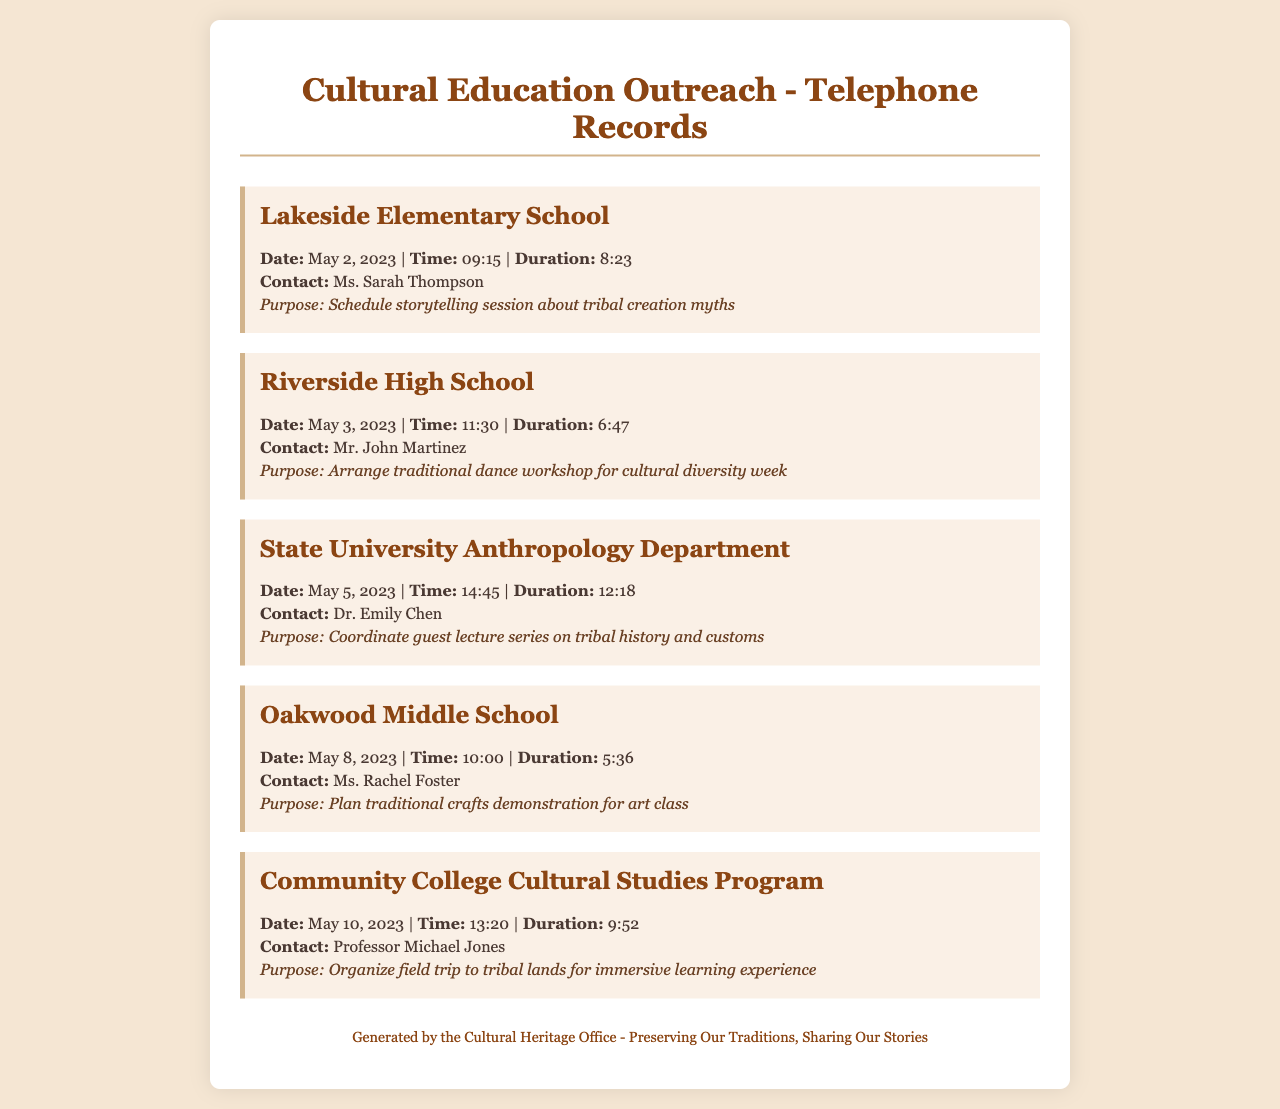What school was contacted on May 2, 2023? The document lists Lakeside Elementary School as the school contacted on that date.
Answer: Lakeside Elementary School Who was the contact person for the Riverside High School call? The record shows that Mr. John Martinez was the contact person for Riverside High School.
Answer: Mr. John Martinez What was the purpose of the call to State University Anthropology Department? The purpose mentioned is to coordinate a guest lecture series on tribal history and customs.
Answer: Coordinate guest lecture series on tribal history and customs How long was the call made to Oakwood Middle School? The duration of the Oakwood Middle School call is listed as 5 minutes and 36 seconds.
Answer: 5:36 What date was the call to Community College Cultural Studies Program made? The call to this program was made on May 10, 2023.
Answer: May 10, 2023 Which educational institution has a traditional dance workshop scheduled? According to the document, Riverside High School has a traditional dance workshop scheduled.
Answer: Riverside High School What was the focus of the storytelling session at Lakeside Elementary? The focus of the storytelling session discussed was about tribal creation myths.
Answer: Tribal creation myths Which contact is associated with the traditional crafts demonstration? The document indicates that Ms. Rachel Foster is associated with the traditional crafts demonstration.
Answer: Ms. Rachel Foster 